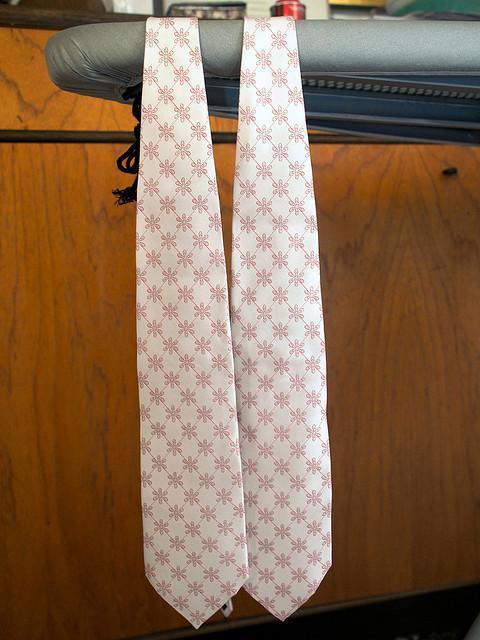How many ties are there?
Give a very brief answer. 1. How many giraffes are in this photo?
Give a very brief answer. 0. 